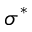Convert formula to latex. <formula><loc_0><loc_0><loc_500><loc_500>\sigma ^ { * }</formula> 